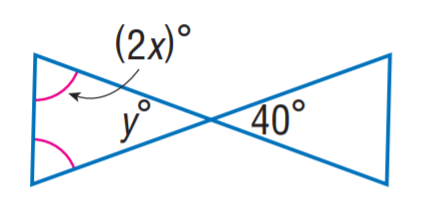Answer the mathemtical geometry problem and directly provide the correct option letter.
Question: Find y.
Choices: A: 30 B: 35 C: 40 D: 45 C 